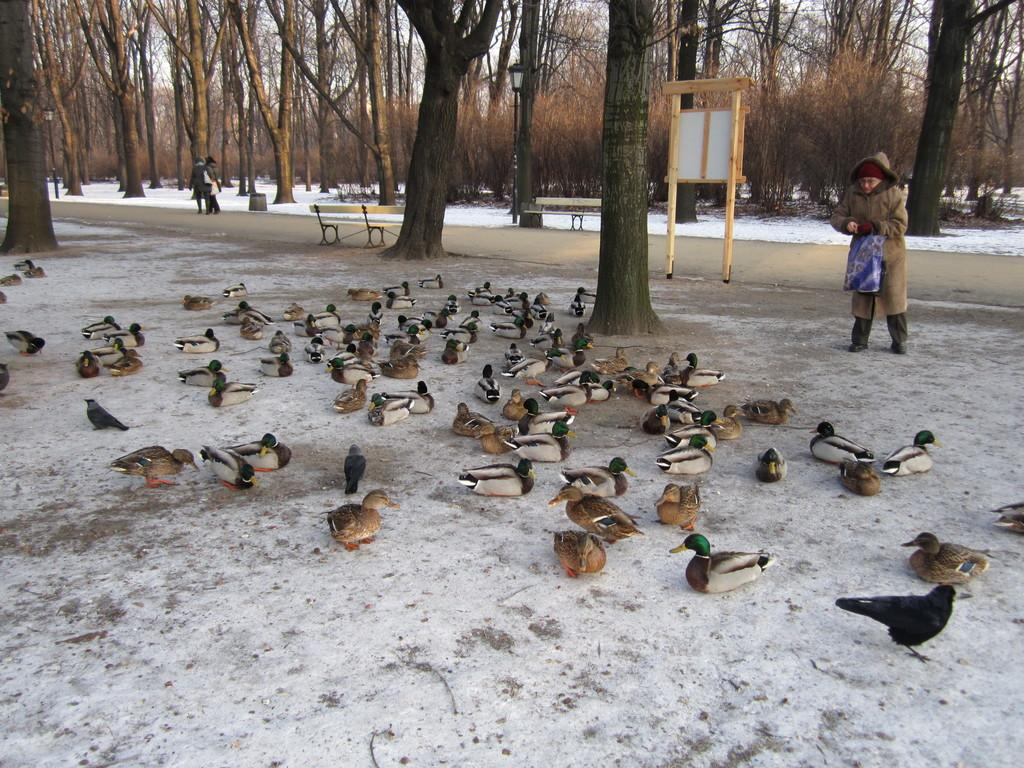What type of animals can be seen on the ground in the image? There are birds on the ground in the image. Can you describe the people in the image? There are people in the image. What type of seating is available in the image? There are benches in the image. What are the poles with lights used for in the image? The poles with lights are used for illumination in the image. What is the wooden object in the image? There is a wooden object in the image, but its specific purpose is not clear from the facts provided. What can be seen in the background of the image? There are trees, snow, and the sky visible in the background of the image. What type of jelly can be seen on the benches in the image? There is no jelly present on the benches in the image. What is the shape of the heart in the image? There is no heart present in the image. 